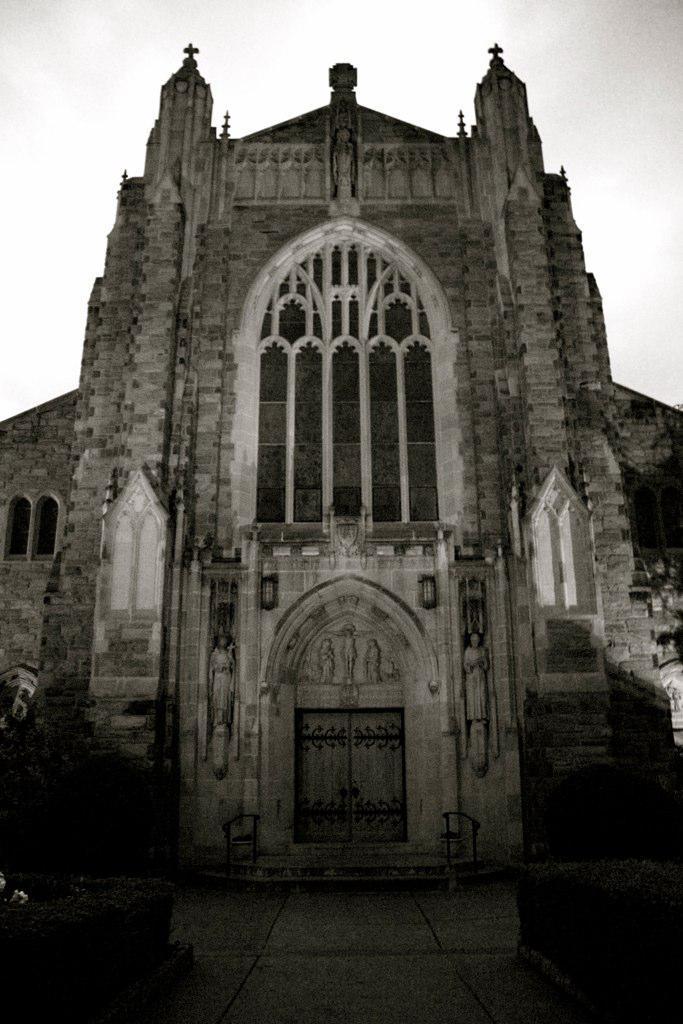In one or two sentences, can you explain what this image depicts? In this image there is a building in the foreground. There is a sky at the top. And there is a floor at the bottom. 